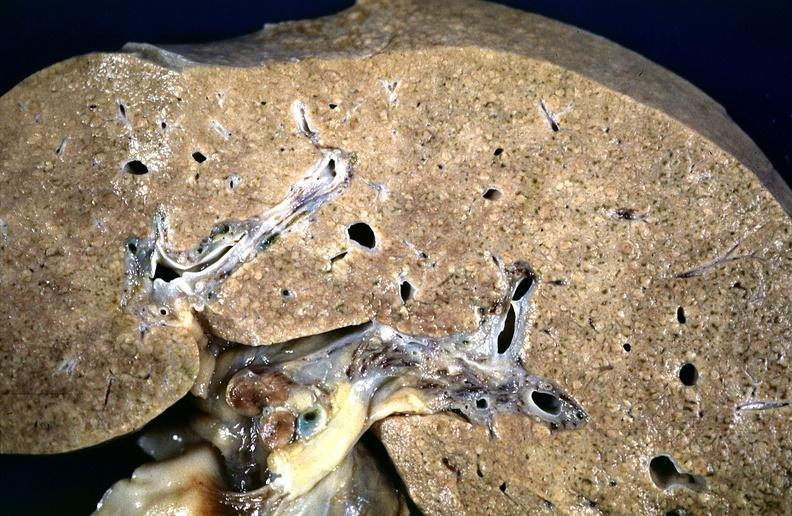s chloramphenicol toxicity present?
Answer the question using a single word or phrase. No 